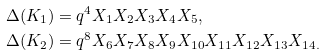<formula> <loc_0><loc_0><loc_500><loc_500>\Delta ( K _ { 1 } ) & = q ^ { 4 } X _ { 1 } X _ { 2 } X _ { 3 } X _ { 4 } X _ { 5 } , \\ \Delta ( K _ { 2 } ) & = q ^ { 8 } X _ { 6 } X _ { 7 } X _ { 8 } X _ { 9 } X _ { 1 0 } X _ { 1 1 } X _ { 1 2 } X _ { 1 3 } X _ { 1 4 . }</formula> 